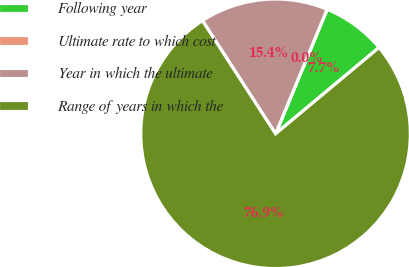<chart> <loc_0><loc_0><loc_500><loc_500><pie_chart><fcel>Following year<fcel>Ultimate rate to which cost<fcel>Year in which the ultimate<fcel>Range of years in which the<nl><fcel>7.69%<fcel>0.0%<fcel>15.38%<fcel>76.92%<nl></chart> 